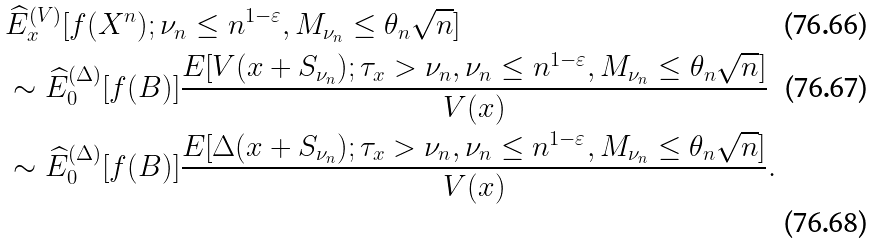Convert formula to latex. <formula><loc_0><loc_0><loc_500><loc_500>& \widehat { E } _ { x } ^ { ( V ) } [ f ( X ^ { n } ) ; \nu _ { n } \leq n ^ { 1 - \varepsilon } , M _ { \nu _ { n } } \leq \theta _ { n } \sqrt { n } ] \\ & \sim \widehat { E } _ { 0 } ^ { ( \Delta ) } [ f ( B ) ] \frac { E [ V ( x + S _ { \nu _ { n } } ) ; \tau _ { x } > \nu _ { n } , \nu _ { n } \leq n ^ { 1 - \varepsilon } , M _ { \nu _ { n } } \leq \theta _ { n } \sqrt { n } ] } { V ( x ) } \\ & \sim \widehat { E } _ { 0 } ^ { ( \Delta ) } [ f ( B ) ] \frac { E [ \Delta ( x + S _ { \nu _ { n } } ) ; \tau _ { x } > \nu _ { n } , \nu _ { n } \leq n ^ { 1 - \varepsilon } , M _ { \nu _ { n } } \leq \theta _ { n } \sqrt { n } ] } { V ( x ) } .</formula> 